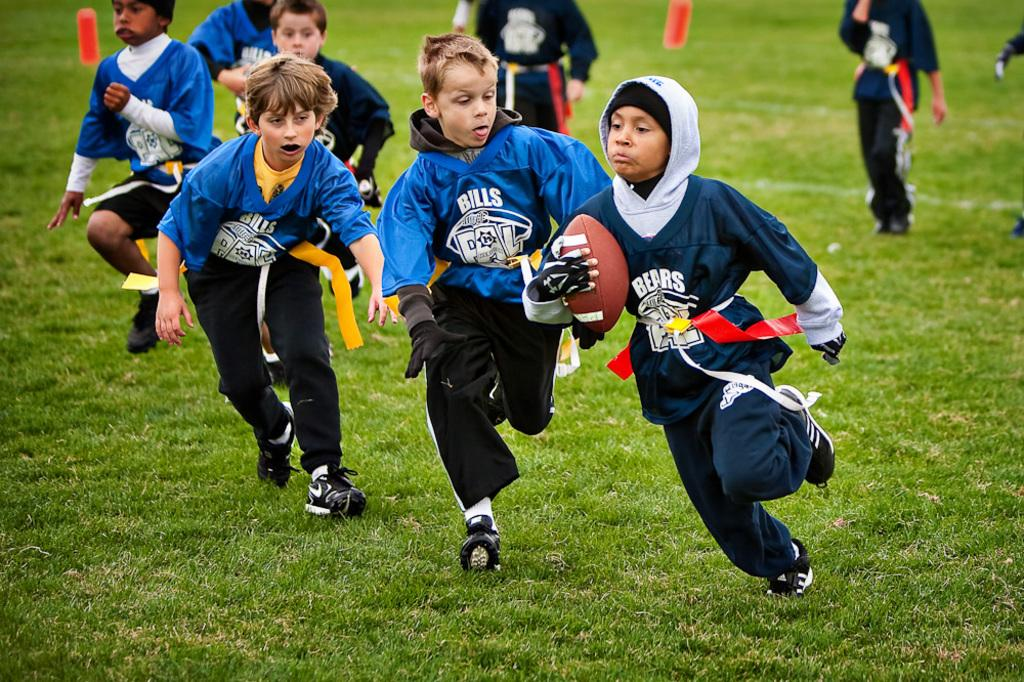<image>
Share a concise interpretation of the image provided. Kids playing for the Bills and the Bears football teams. 